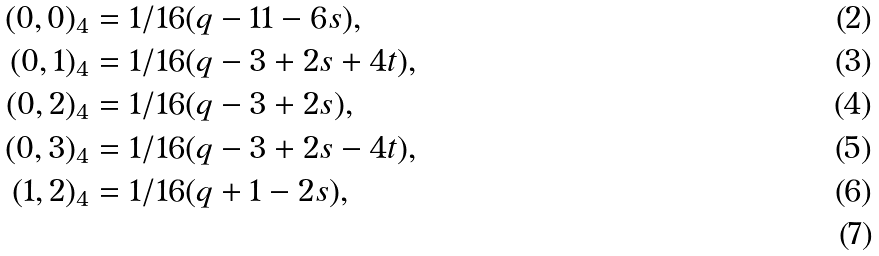<formula> <loc_0><loc_0><loc_500><loc_500>( 0 , 0 ) _ { 4 } & = 1 / 1 6 ( q - 1 1 - 6 s ) , \\ ( 0 , 1 ) _ { 4 } & = 1 / 1 6 ( q - 3 + 2 s + 4 t ) , \\ ( 0 , 2 ) _ { 4 } & = 1 / 1 6 ( q - 3 + 2 s ) , \\ ( 0 , 3 ) _ { 4 } & = 1 / 1 6 ( q - 3 + 2 s - 4 t ) , \\ ( 1 , 2 ) _ { 4 } & = 1 / 1 6 ( q + 1 - 2 s ) , \\</formula> 